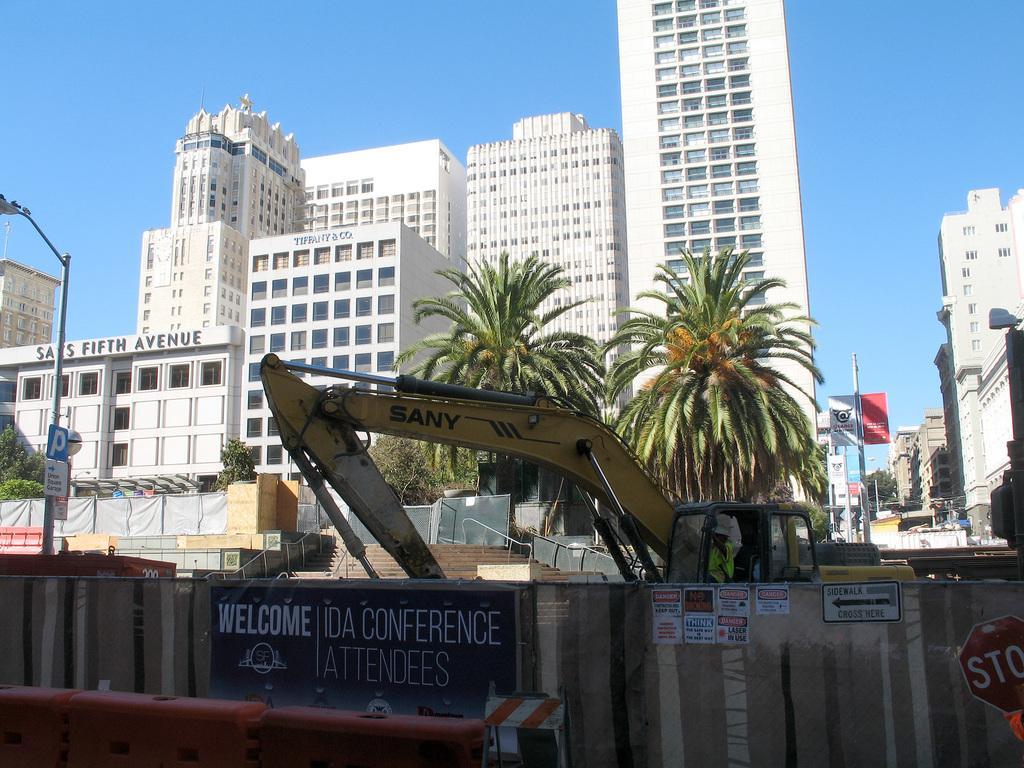Can you describe this image briefly? In this image I can see light poles, banners, boards, hoarding, posters, signboards, buildings, trees, steps, crane, person, blue sky and things.   